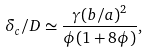Convert formula to latex. <formula><loc_0><loc_0><loc_500><loc_500>\delta _ { c } / D \simeq \frac { \gamma ( b / a ) ^ { 2 } } { \phi ( 1 + 8 \phi ) } ,</formula> 